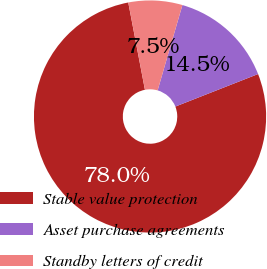Convert chart to OTSL. <chart><loc_0><loc_0><loc_500><loc_500><pie_chart><fcel>Stable value protection<fcel>Asset purchase agreements<fcel>Standby letters of credit<nl><fcel>77.96%<fcel>14.54%<fcel>7.5%<nl></chart> 